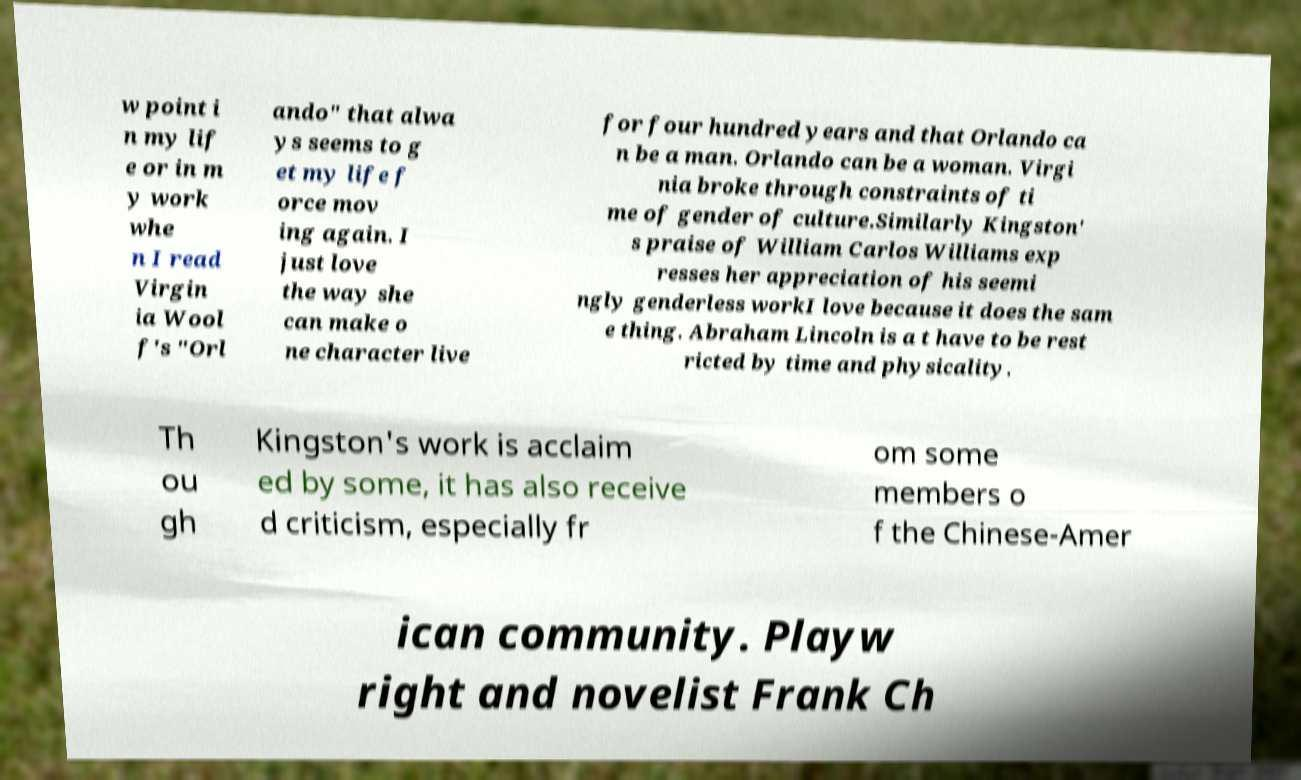What messages or text are displayed in this image? I need them in a readable, typed format. w point i n my lif e or in m y work whe n I read Virgin ia Wool f's "Orl ando" that alwa ys seems to g et my life f orce mov ing again. I just love the way she can make o ne character live for four hundred years and that Orlando ca n be a man. Orlando can be a woman. Virgi nia broke through constraints of ti me of gender of culture.Similarly Kingston' s praise of William Carlos Williams exp resses her appreciation of his seemi ngly genderless workI love because it does the sam e thing. Abraham Lincoln is a t have to be rest ricted by time and physicality. Th ou gh Kingston's work is acclaim ed by some, it has also receive d criticism, especially fr om some members o f the Chinese-Amer ican community. Playw right and novelist Frank Ch 